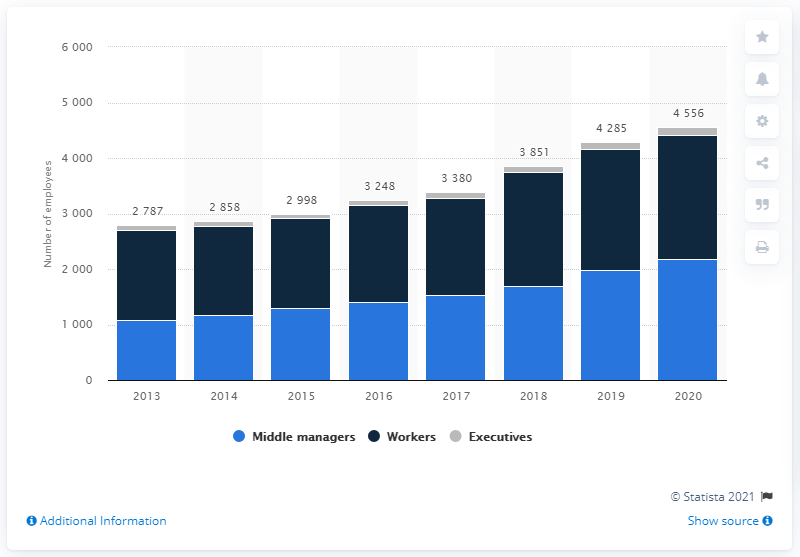Give some essential details in this illustration. In 2020, Ferrari employed a total of 137 executive employees. In 2020, Ferrari had a total of 4,556 employees on its payroll. 